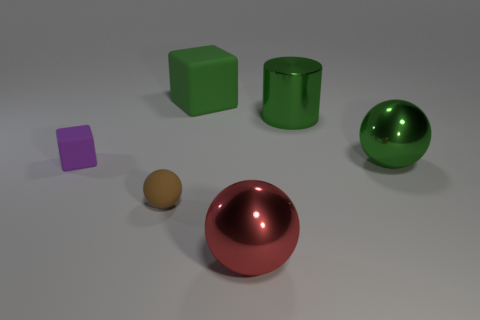What number of small purple rubber things are the same shape as the red thing?
Your response must be concise. 0. Does the cylinder have the same color as the large rubber cube?
Your answer should be very brief. Yes. The big green object in front of the block in front of the big green block behind the tiny rubber sphere is made of what material?
Offer a very short reply. Metal. There is a big green rubber cube; are there any tiny objects in front of it?
Provide a short and direct response. Yes. There is a green rubber thing that is the same size as the green ball; what shape is it?
Provide a short and direct response. Cube. Is the big red thing made of the same material as the big cube?
Offer a very short reply. No. How many shiny things are purple blocks or large objects?
Your answer should be compact. 3. What is the shape of the metallic thing that is the same color as the cylinder?
Give a very brief answer. Sphere. There is a matte cube that is behind the big green metal cylinder; does it have the same color as the metal cylinder?
Your answer should be very brief. Yes. There is a shiny object in front of the metallic sphere that is behind the big red metallic ball; what is its shape?
Your answer should be compact. Sphere. 